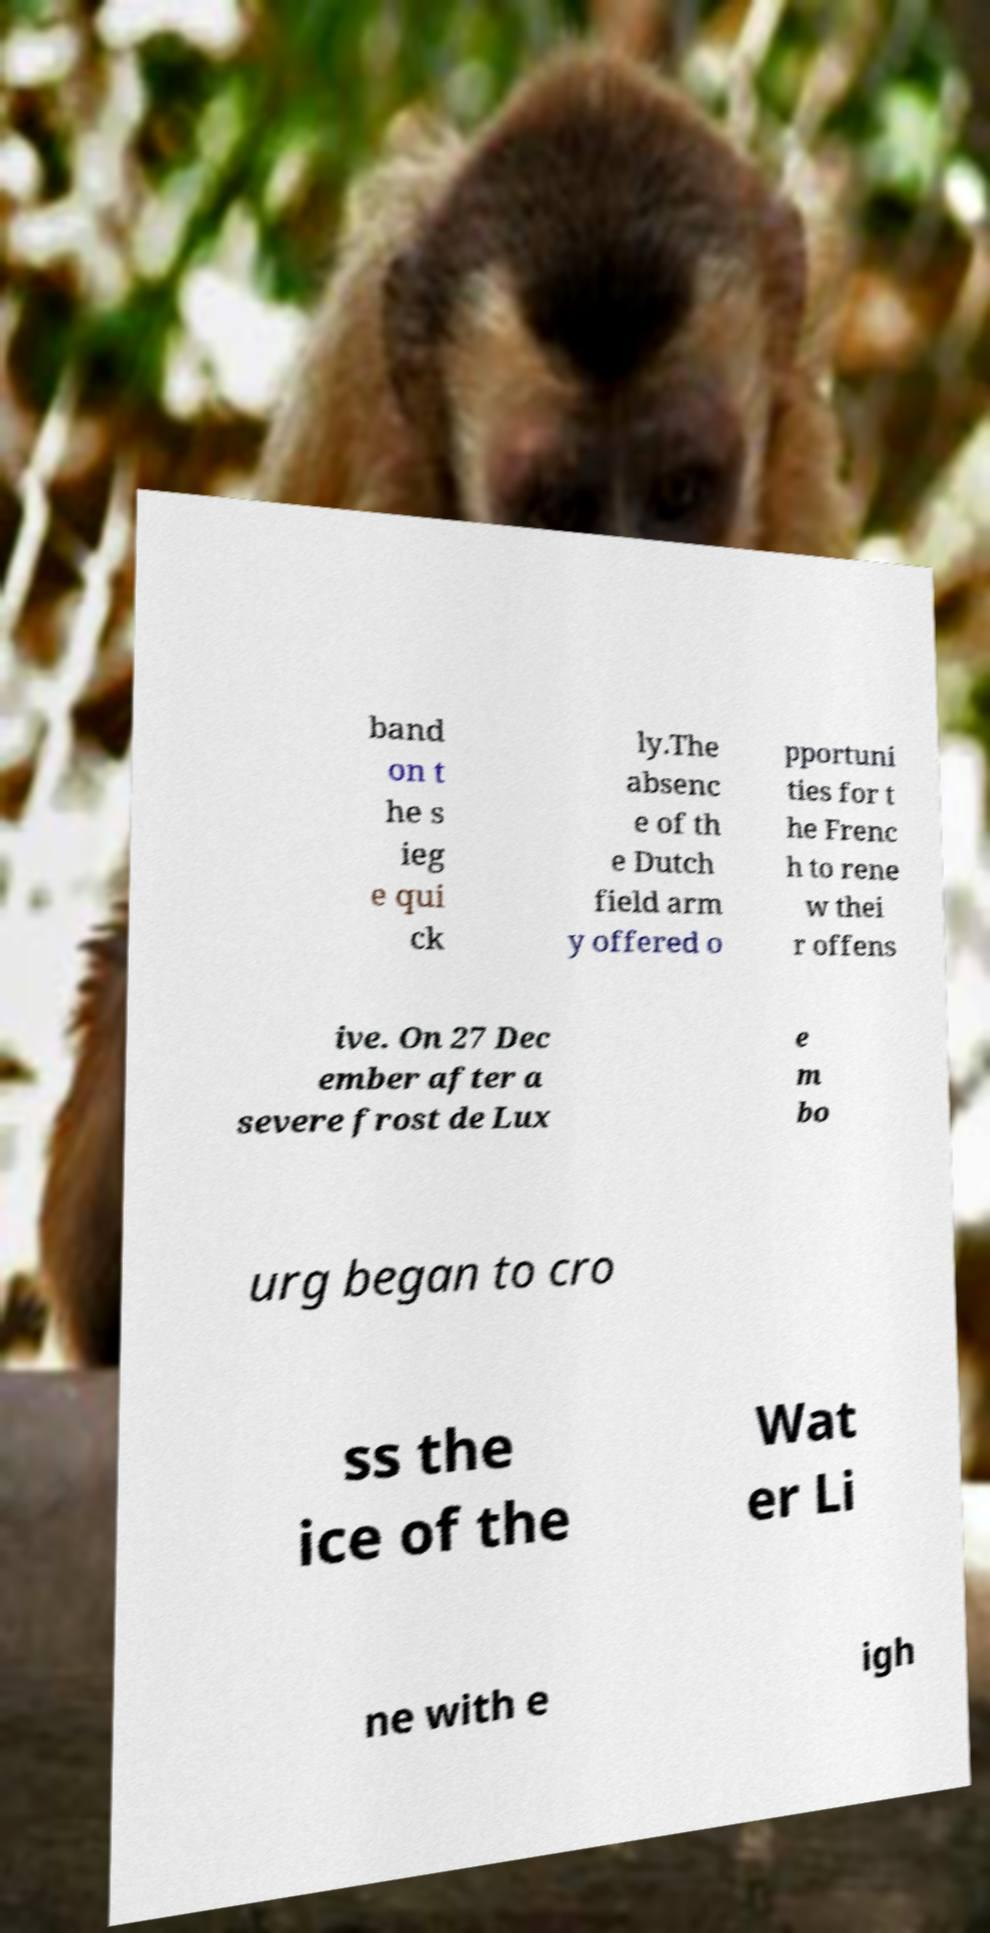Can you read and provide the text displayed in the image?This photo seems to have some interesting text. Can you extract and type it out for me? band on t he s ieg e qui ck ly.The absenc e of th e Dutch field arm y offered o pportuni ties for t he Frenc h to rene w thei r offens ive. On 27 Dec ember after a severe frost de Lux e m bo urg began to cro ss the ice of the Wat er Li ne with e igh 